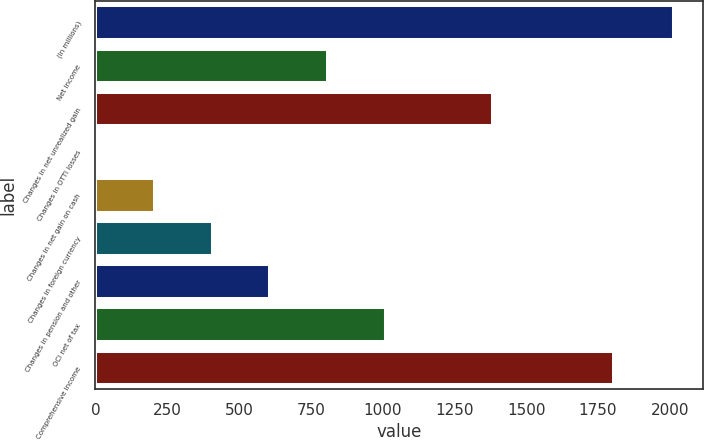Convert chart. <chart><loc_0><loc_0><loc_500><loc_500><bar_chart><fcel>(In millions)<fcel>Net income<fcel>Changes in net unrealized gain<fcel>Changes in OTTI losses<fcel>Changes in net gain on cash<fcel>Changes in foreign currency<fcel>Changes in pension and other<fcel>OCI net of tax<fcel>Comprehensive income<nl><fcel>2014<fcel>809.8<fcel>1383<fcel>7<fcel>207.7<fcel>408.4<fcel>609.1<fcel>1010.5<fcel>1805<nl></chart> 